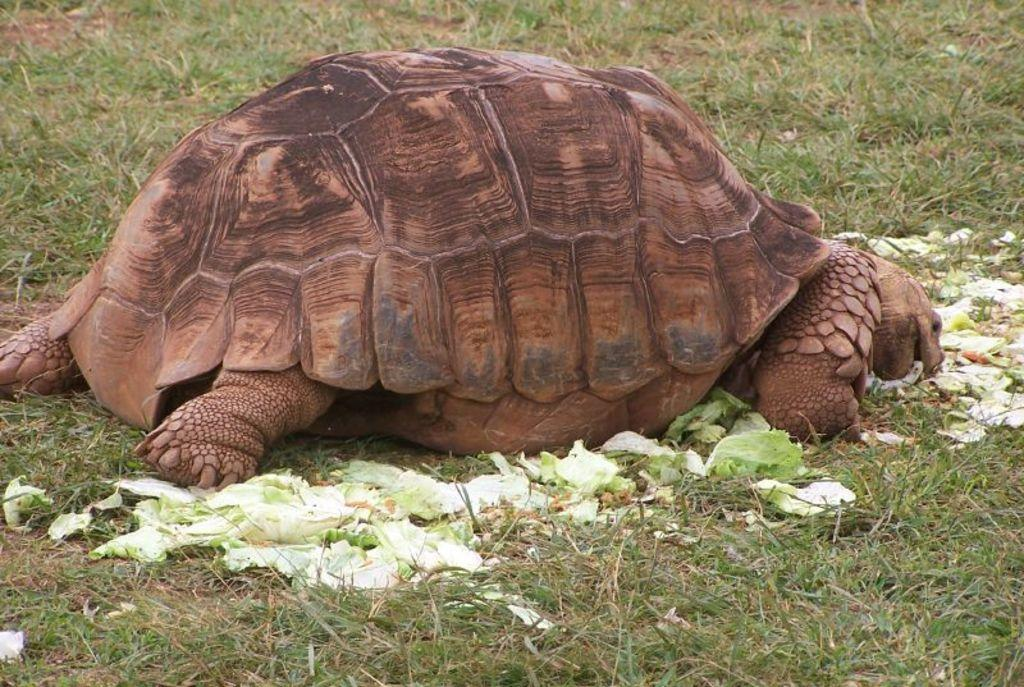What animal can be seen on the ground in the image? There is a tortoise on the ground in the image. What type of vegetation is present on the ground? There is grass on the ground in the image. What is located beside the tortoise? There is cabbage beside the tortoise in the image. What type of flame can be seen coming from the tortoise's legs in the image? There is no flame present in the image, and the tortoise does not have legs. 